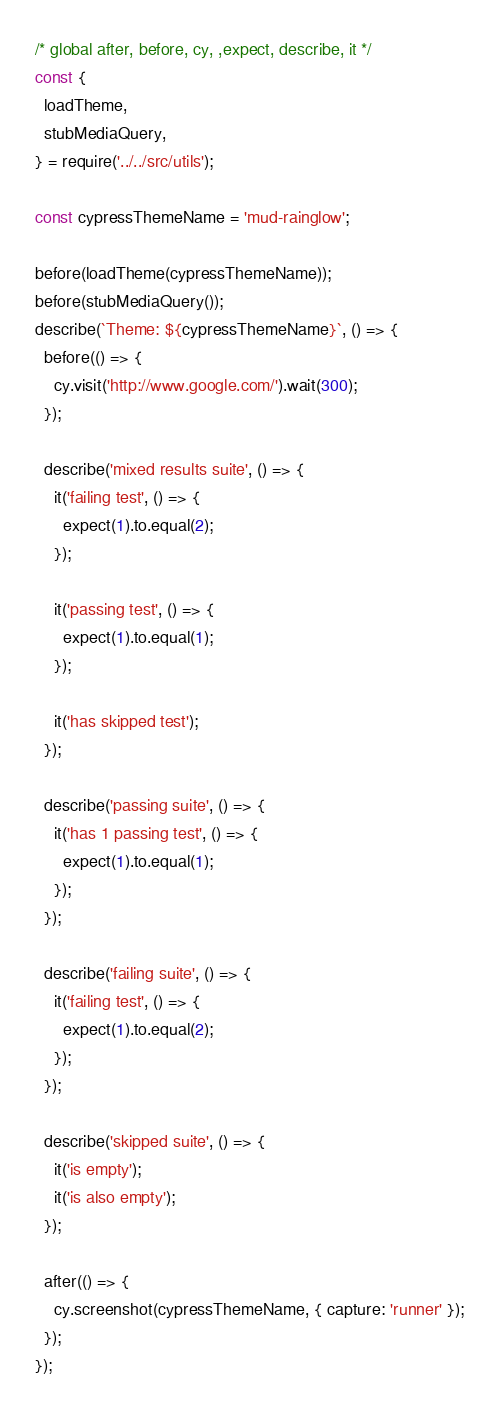<code> <loc_0><loc_0><loc_500><loc_500><_JavaScript_>/* global after, before, cy, ,expect, describe, it */
const {
  loadTheme,
  stubMediaQuery,
} = require('../../src/utils');

const cypressThemeName = 'mud-rainglow';

before(loadTheme(cypressThemeName));
before(stubMediaQuery());
describe(`Theme: ${cypressThemeName}`, () => {
  before(() => {
    cy.visit('http://www.google.com/').wait(300);
  });

  describe('mixed results suite', () => {
    it('failing test', () => {
      expect(1).to.equal(2);
    });

    it('passing test', () => {
      expect(1).to.equal(1);
    });

    it('has skipped test');
  });

  describe('passing suite', () => {
    it('has 1 passing test', () => {
      expect(1).to.equal(1);
    });
  });

  describe('failing suite', () => {
    it('failing test', () => {
      expect(1).to.equal(2);
    });
  });

  describe('skipped suite', () => {
    it('is empty');
    it('is also empty');
  });

  after(() => {
    cy.screenshot(cypressThemeName, { capture: 'runner' });
  });
});
</code> 